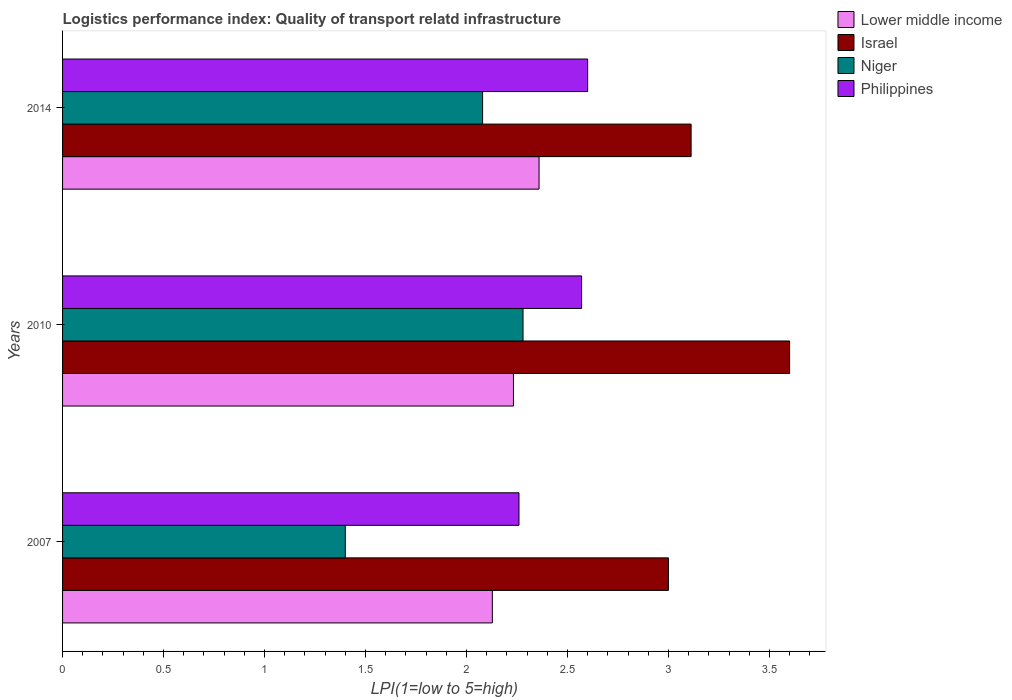Are the number of bars per tick equal to the number of legend labels?
Give a very brief answer. Yes. Are the number of bars on each tick of the Y-axis equal?
Give a very brief answer. Yes. How many bars are there on the 3rd tick from the bottom?
Offer a terse response. 4. What is the logistics performance index in Niger in 2010?
Offer a very short reply. 2.28. Across all years, what is the maximum logistics performance index in Niger?
Ensure brevity in your answer.  2.28. Across all years, what is the minimum logistics performance index in Lower middle income?
Your answer should be very brief. 2.13. In which year was the logistics performance index in Lower middle income maximum?
Your answer should be very brief. 2014. In which year was the logistics performance index in Israel minimum?
Make the answer very short. 2007. What is the total logistics performance index in Lower middle income in the graph?
Provide a succinct answer. 6.72. What is the difference between the logistics performance index in Israel in 2007 and that in 2014?
Make the answer very short. -0.11. What is the difference between the logistics performance index in Philippines in 2010 and the logistics performance index in Lower middle income in 2014?
Provide a short and direct response. 0.21. What is the average logistics performance index in Niger per year?
Provide a short and direct response. 1.92. In the year 2014, what is the difference between the logistics performance index in Lower middle income and logistics performance index in Niger?
Your answer should be compact. 0.28. What is the ratio of the logistics performance index in Israel in 2007 to that in 2014?
Offer a terse response. 0.96. Is the logistics performance index in Lower middle income in 2007 less than that in 2010?
Your answer should be very brief. Yes. Is the difference between the logistics performance index in Lower middle income in 2007 and 2014 greater than the difference between the logistics performance index in Niger in 2007 and 2014?
Ensure brevity in your answer.  Yes. What is the difference between the highest and the second highest logistics performance index in Philippines?
Offer a terse response. 0.03. What is the difference between the highest and the lowest logistics performance index in Israel?
Give a very brief answer. 0.6. What does the 2nd bar from the top in 2007 represents?
Offer a terse response. Niger. What does the 2nd bar from the bottom in 2010 represents?
Keep it short and to the point. Israel. How many bars are there?
Make the answer very short. 12. Are all the bars in the graph horizontal?
Keep it short and to the point. Yes. Does the graph contain any zero values?
Provide a short and direct response. No. How many legend labels are there?
Your response must be concise. 4. What is the title of the graph?
Your answer should be compact. Logistics performance index: Quality of transport relatd infrastructure. Does "Finland" appear as one of the legend labels in the graph?
Give a very brief answer. No. What is the label or title of the X-axis?
Provide a succinct answer. LPI(1=low to 5=high). What is the LPI(1=low to 5=high) of Lower middle income in 2007?
Ensure brevity in your answer.  2.13. What is the LPI(1=low to 5=high) of Niger in 2007?
Your answer should be compact. 1.4. What is the LPI(1=low to 5=high) in Philippines in 2007?
Your response must be concise. 2.26. What is the LPI(1=low to 5=high) of Lower middle income in 2010?
Your answer should be very brief. 2.23. What is the LPI(1=low to 5=high) of Israel in 2010?
Your response must be concise. 3.6. What is the LPI(1=low to 5=high) of Niger in 2010?
Make the answer very short. 2.28. What is the LPI(1=low to 5=high) of Philippines in 2010?
Your answer should be compact. 2.57. What is the LPI(1=low to 5=high) of Lower middle income in 2014?
Your response must be concise. 2.36. What is the LPI(1=low to 5=high) in Israel in 2014?
Your response must be concise. 3.11. What is the LPI(1=low to 5=high) in Niger in 2014?
Keep it short and to the point. 2.08. What is the LPI(1=low to 5=high) of Philippines in 2014?
Make the answer very short. 2.6. Across all years, what is the maximum LPI(1=low to 5=high) in Lower middle income?
Offer a terse response. 2.36. Across all years, what is the maximum LPI(1=low to 5=high) of Niger?
Make the answer very short. 2.28. Across all years, what is the minimum LPI(1=low to 5=high) of Lower middle income?
Provide a short and direct response. 2.13. Across all years, what is the minimum LPI(1=low to 5=high) in Israel?
Your answer should be very brief. 3. Across all years, what is the minimum LPI(1=low to 5=high) in Philippines?
Keep it short and to the point. 2.26. What is the total LPI(1=low to 5=high) in Lower middle income in the graph?
Give a very brief answer. 6.72. What is the total LPI(1=low to 5=high) in Israel in the graph?
Make the answer very short. 9.71. What is the total LPI(1=low to 5=high) in Niger in the graph?
Your answer should be compact. 5.76. What is the total LPI(1=low to 5=high) of Philippines in the graph?
Make the answer very short. 7.43. What is the difference between the LPI(1=low to 5=high) of Lower middle income in 2007 and that in 2010?
Offer a terse response. -0.1. What is the difference between the LPI(1=low to 5=high) in Israel in 2007 and that in 2010?
Offer a very short reply. -0.6. What is the difference between the LPI(1=low to 5=high) in Niger in 2007 and that in 2010?
Make the answer very short. -0.88. What is the difference between the LPI(1=low to 5=high) in Philippines in 2007 and that in 2010?
Keep it short and to the point. -0.31. What is the difference between the LPI(1=low to 5=high) in Lower middle income in 2007 and that in 2014?
Offer a terse response. -0.23. What is the difference between the LPI(1=low to 5=high) in Israel in 2007 and that in 2014?
Your response must be concise. -0.11. What is the difference between the LPI(1=low to 5=high) in Niger in 2007 and that in 2014?
Provide a short and direct response. -0.68. What is the difference between the LPI(1=low to 5=high) of Philippines in 2007 and that in 2014?
Provide a short and direct response. -0.34. What is the difference between the LPI(1=low to 5=high) in Lower middle income in 2010 and that in 2014?
Give a very brief answer. -0.13. What is the difference between the LPI(1=low to 5=high) of Israel in 2010 and that in 2014?
Provide a short and direct response. 0.49. What is the difference between the LPI(1=low to 5=high) in Niger in 2010 and that in 2014?
Your answer should be very brief. 0.2. What is the difference between the LPI(1=low to 5=high) of Philippines in 2010 and that in 2014?
Keep it short and to the point. -0.03. What is the difference between the LPI(1=low to 5=high) of Lower middle income in 2007 and the LPI(1=low to 5=high) of Israel in 2010?
Make the answer very short. -1.47. What is the difference between the LPI(1=low to 5=high) in Lower middle income in 2007 and the LPI(1=low to 5=high) in Niger in 2010?
Offer a terse response. -0.15. What is the difference between the LPI(1=low to 5=high) of Lower middle income in 2007 and the LPI(1=low to 5=high) of Philippines in 2010?
Offer a terse response. -0.44. What is the difference between the LPI(1=low to 5=high) of Israel in 2007 and the LPI(1=low to 5=high) of Niger in 2010?
Your answer should be compact. 0.72. What is the difference between the LPI(1=low to 5=high) in Israel in 2007 and the LPI(1=low to 5=high) in Philippines in 2010?
Your answer should be very brief. 0.43. What is the difference between the LPI(1=low to 5=high) in Niger in 2007 and the LPI(1=low to 5=high) in Philippines in 2010?
Provide a short and direct response. -1.17. What is the difference between the LPI(1=low to 5=high) of Lower middle income in 2007 and the LPI(1=low to 5=high) of Israel in 2014?
Provide a succinct answer. -0.98. What is the difference between the LPI(1=low to 5=high) of Lower middle income in 2007 and the LPI(1=low to 5=high) of Niger in 2014?
Provide a succinct answer. 0.05. What is the difference between the LPI(1=low to 5=high) of Lower middle income in 2007 and the LPI(1=low to 5=high) of Philippines in 2014?
Ensure brevity in your answer.  -0.47. What is the difference between the LPI(1=low to 5=high) in Israel in 2007 and the LPI(1=low to 5=high) in Niger in 2014?
Your answer should be compact. 0.92. What is the difference between the LPI(1=low to 5=high) in Niger in 2007 and the LPI(1=low to 5=high) in Philippines in 2014?
Your response must be concise. -1.2. What is the difference between the LPI(1=low to 5=high) in Lower middle income in 2010 and the LPI(1=low to 5=high) in Israel in 2014?
Provide a succinct answer. -0.88. What is the difference between the LPI(1=low to 5=high) in Lower middle income in 2010 and the LPI(1=low to 5=high) in Niger in 2014?
Provide a succinct answer. 0.15. What is the difference between the LPI(1=low to 5=high) of Lower middle income in 2010 and the LPI(1=low to 5=high) of Philippines in 2014?
Provide a short and direct response. -0.37. What is the difference between the LPI(1=low to 5=high) in Israel in 2010 and the LPI(1=low to 5=high) in Niger in 2014?
Ensure brevity in your answer.  1.52. What is the difference between the LPI(1=low to 5=high) in Israel in 2010 and the LPI(1=low to 5=high) in Philippines in 2014?
Offer a very short reply. 1. What is the difference between the LPI(1=low to 5=high) in Niger in 2010 and the LPI(1=low to 5=high) in Philippines in 2014?
Ensure brevity in your answer.  -0.32. What is the average LPI(1=low to 5=high) in Lower middle income per year?
Keep it short and to the point. 2.24. What is the average LPI(1=low to 5=high) of Israel per year?
Provide a short and direct response. 3.24. What is the average LPI(1=low to 5=high) in Niger per year?
Your answer should be compact. 1.92. What is the average LPI(1=low to 5=high) of Philippines per year?
Provide a succinct answer. 2.48. In the year 2007, what is the difference between the LPI(1=low to 5=high) of Lower middle income and LPI(1=low to 5=high) of Israel?
Ensure brevity in your answer.  -0.87. In the year 2007, what is the difference between the LPI(1=low to 5=high) of Lower middle income and LPI(1=low to 5=high) of Niger?
Ensure brevity in your answer.  0.73. In the year 2007, what is the difference between the LPI(1=low to 5=high) of Lower middle income and LPI(1=low to 5=high) of Philippines?
Provide a short and direct response. -0.13. In the year 2007, what is the difference between the LPI(1=low to 5=high) of Israel and LPI(1=low to 5=high) of Philippines?
Offer a very short reply. 0.74. In the year 2007, what is the difference between the LPI(1=low to 5=high) of Niger and LPI(1=low to 5=high) of Philippines?
Provide a succinct answer. -0.86. In the year 2010, what is the difference between the LPI(1=low to 5=high) of Lower middle income and LPI(1=low to 5=high) of Israel?
Your answer should be compact. -1.37. In the year 2010, what is the difference between the LPI(1=low to 5=high) in Lower middle income and LPI(1=low to 5=high) in Niger?
Provide a succinct answer. -0.05. In the year 2010, what is the difference between the LPI(1=low to 5=high) of Lower middle income and LPI(1=low to 5=high) of Philippines?
Keep it short and to the point. -0.34. In the year 2010, what is the difference between the LPI(1=low to 5=high) of Israel and LPI(1=low to 5=high) of Niger?
Your answer should be compact. 1.32. In the year 2010, what is the difference between the LPI(1=low to 5=high) in Israel and LPI(1=low to 5=high) in Philippines?
Provide a short and direct response. 1.03. In the year 2010, what is the difference between the LPI(1=low to 5=high) in Niger and LPI(1=low to 5=high) in Philippines?
Give a very brief answer. -0.29. In the year 2014, what is the difference between the LPI(1=low to 5=high) in Lower middle income and LPI(1=low to 5=high) in Israel?
Provide a short and direct response. -0.75. In the year 2014, what is the difference between the LPI(1=low to 5=high) in Lower middle income and LPI(1=low to 5=high) in Niger?
Keep it short and to the point. 0.28. In the year 2014, what is the difference between the LPI(1=low to 5=high) of Lower middle income and LPI(1=low to 5=high) of Philippines?
Keep it short and to the point. -0.24. In the year 2014, what is the difference between the LPI(1=low to 5=high) of Israel and LPI(1=low to 5=high) of Niger?
Ensure brevity in your answer.  1.03. In the year 2014, what is the difference between the LPI(1=low to 5=high) of Israel and LPI(1=low to 5=high) of Philippines?
Your answer should be very brief. 0.51. In the year 2014, what is the difference between the LPI(1=low to 5=high) in Niger and LPI(1=low to 5=high) in Philippines?
Provide a succinct answer. -0.52. What is the ratio of the LPI(1=low to 5=high) of Lower middle income in 2007 to that in 2010?
Offer a very short reply. 0.95. What is the ratio of the LPI(1=low to 5=high) of Israel in 2007 to that in 2010?
Make the answer very short. 0.83. What is the ratio of the LPI(1=low to 5=high) in Niger in 2007 to that in 2010?
Your answer should be compact. 0.61. What is the ratio of the LPI(1=low to 5=high) of Philippines in 2007 to that in 2010?
Give a very brief answer. 0.88. What is the ratio of the LPI(1=low to 5=high) in Lower middle income in 2007 to that in 2014?
Offer a very short reply. 0.9. What is the ratio of the LPI(1=low to 5=high) of Israel in 2007 to that in 2014?
Your answer should be compact. 0.96. What is the ratio of the LPI(1=low to 5=high) of Niger in 2007 to that in 2014?
Offer a very short reply. 0.67. What is the ratio of the LPI(1=low to 5=high) in Philippines in 2007 to that in 2014?
Offer a terse response. 0.87. What is the ratio of the LPI(1=low to 5=high) in Lower middle income in 2010 to that in 2014?
Ensure brevity in your answer.  0.95. What is the ratio of the LPI(1=low to 5=high) of Israel in 2010 to that in 2014?
Ensure brevity in your answer.  1.16. What is the ratio of the LPI(1=low to 5=high) in Niger in 2010 to that in 2014?
Provide a succinct answer. 1.1. What is the difference between the highest and the second highest LPI(1=low to 5=high) in Lower middle income?
Provide a succinct answer. 0.13. What is the difference between the highest and the second highest LPI(1=low to 5=high) in Israel?
Keep it short and to the point. 0.49. What is the difference between the highest and the second highest LPI(1=low to 5=high) of Niger?
Make the answer very short. 0.2. What is the difference between the highest and the second highest LPI(1=low to 5=high) of Philippines?
Your answer should be compact. 0.03. What is the difference between the highest and the lowest LPI(1=low to 5=high) in Lower middle income?
Keep it short and to the point. 0.23. What is the difference between the highest and the lowest LPI(1=low to 5=high) of Philippines?
Offer a terse response. 0.34. 